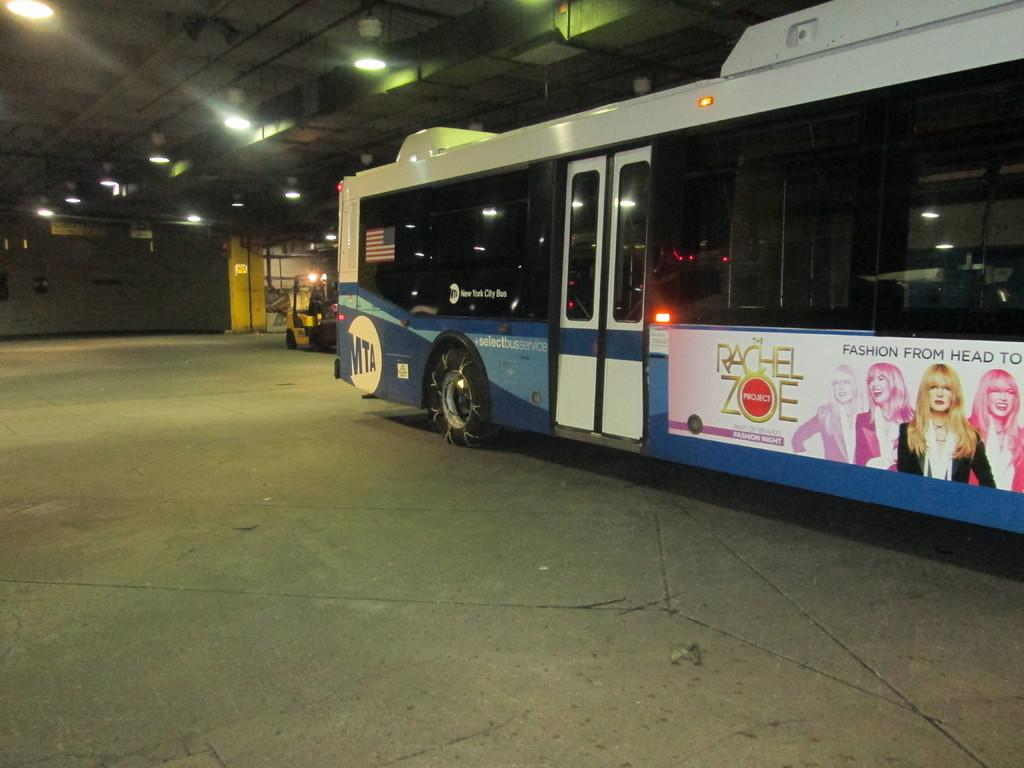What type of vehicle is the main subject in the image? There is a bus in the image. Can you describe the other vehicle in the image? There is another vehicle behind the bus in the image. Where are the vehicles located? Both vehicles are kept inside a compartment. What can be seen on the roof of the compartment? There are a lot of lights on the roof of the compartment. How many cans of soda are visible on the bus in the image? There is no mention of cans of soda in the image, so it cannot be determined from the provided facts. 